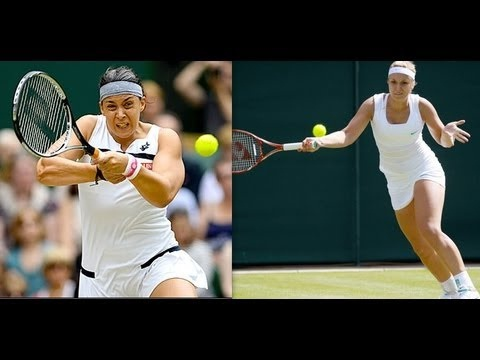Describe the objects in this image and their specific colors. I can see people in black, lightgray, darkgray, tan, and olive tones, people in black, lightgray, gray, olive, and darkgray tones, tennis racket in black, darkgray, gray, and lightgray tones, people in black, gray, tan, and darkgray tones, and people in black, gray, and tan tones in this image. 